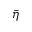<formula> <loc_0><loc_0><loc_500><loc_500>\bar { \eta }</formula> 